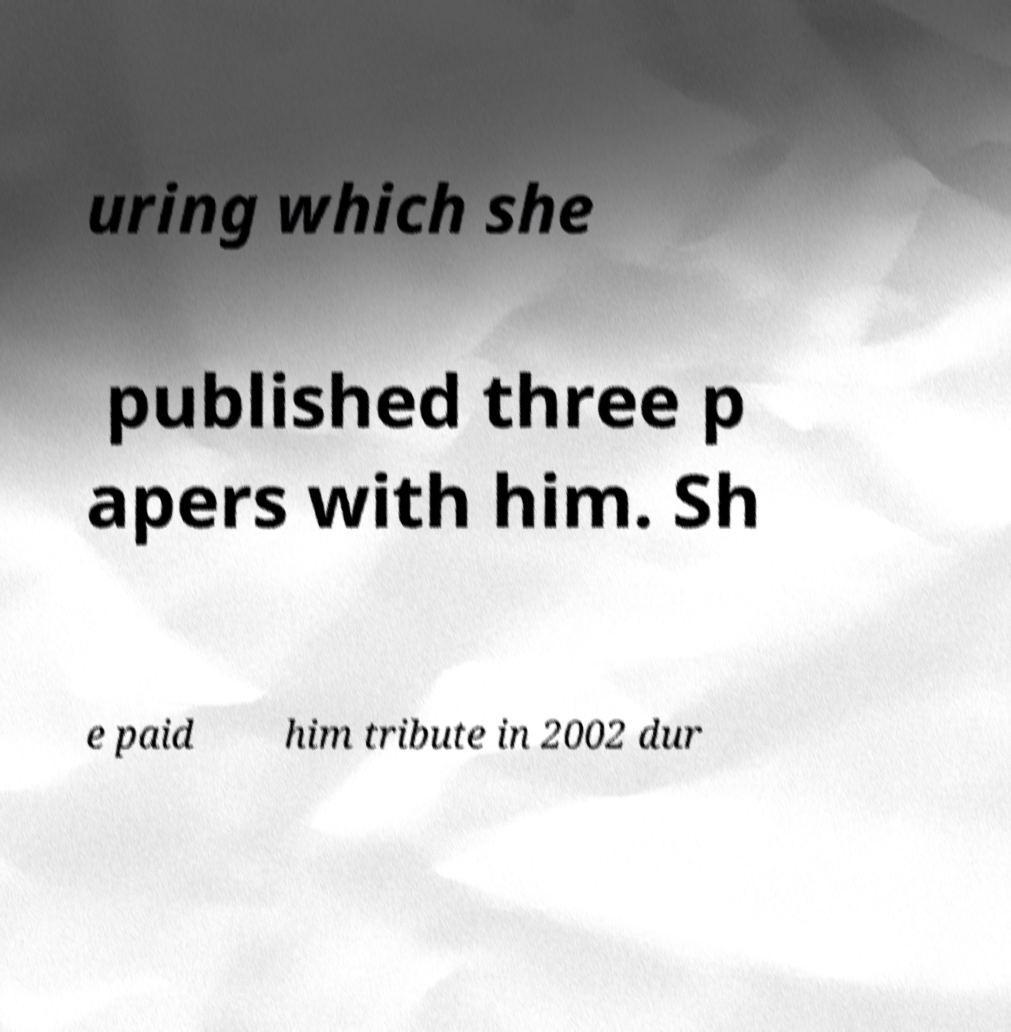What messages or text are displayed in this image? I need them in a readable, typed format. uring which she published three p apers with him. Sh e paid him tribute in 2002 dur 